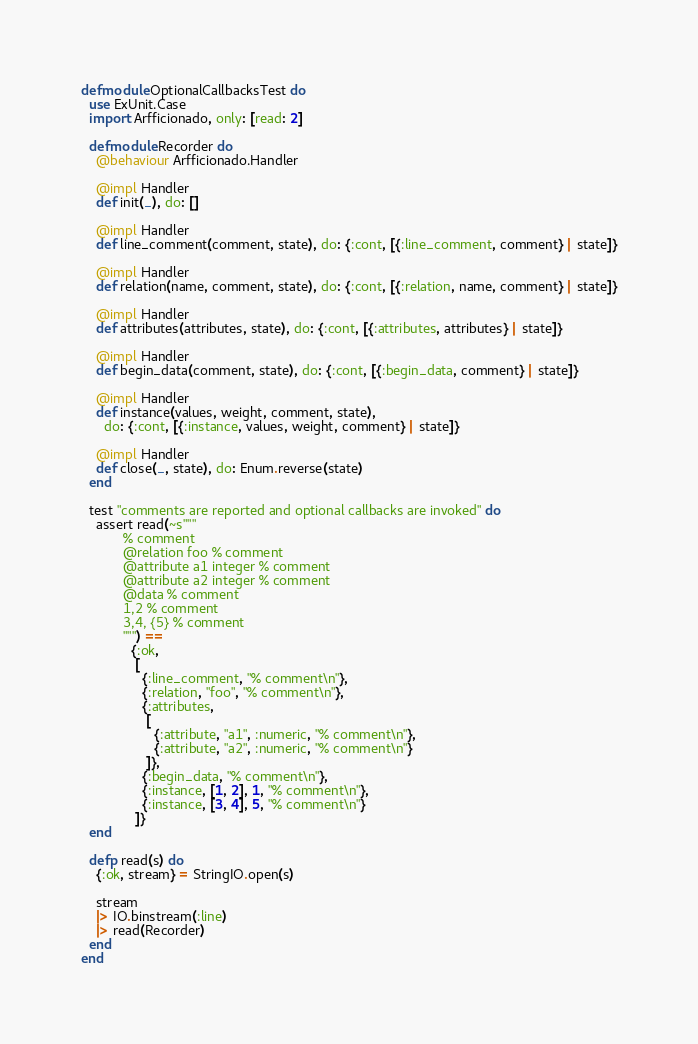<code> <loc_0><loc_0><loc_500><loc_500><_Elixir_>defmodule OptionalCallbacksTest do
  use ExUnit.Case
  import Arfficionado, only: [read: 2]

  defmodule Recorder do
    @behaviour Arfficionado.Handler

    @impl Handler
    def init(_), do: []

    @impl Handler
    def line_comment(comment, state), do: {:cont, [{:line_comment, comment} | state]}

    @impl Handler
    def relation(name, comment, state), do: {:cont, [{:relation, name, comment} | state]}

    @impl Handler
    def attributes(attributes, state), do: {:cont, [{:attributes, attributes} | state]}

    @impl Handler
    def begin_data(comment, state), do: {:cont, [{:begin_data, comment} | state]}

    @impl Handler
    def instance(values, weight, comment, state),
      do: {:cont, [{:instance, values, weight, comment} | state]}

    @impl Handler
    def close(_, state), do: Enum.reverse(state)
  end

  test "comments are reported and optional callbacks are invoked" do
    assert read(~s"""
           % comment
           @relation foo % comment
           @attribute a1 integer % comment
           @attribute a2 integer % comment
           @data % comment
           1,2 % comment
           3,4, {5} % comment
           """) ==
             {:ok,
              [
                {:line_comment, "% comment\n"},
                {:relation, "foo", "% comment\n"},
                {:attributes,
                 [
                   {:attribute, "a1", :numeric, "% comment\n"},
                   {:attribute, "a2", :numeric, "% comment\n"}
                 ]},
                {:begin_data, "% comment\n"},
                {:instance, [1, 2], 1, "% comment\n"},
                {:instance, [3, 4], 5, "% comment\n"}
              ]}
  end

  defp read(s) do
    {:ok, stream} = StringIO.open(s)

    stream
    |> IO.binstream(:line)
    |> read(Recorder)
  end
end
</code> 